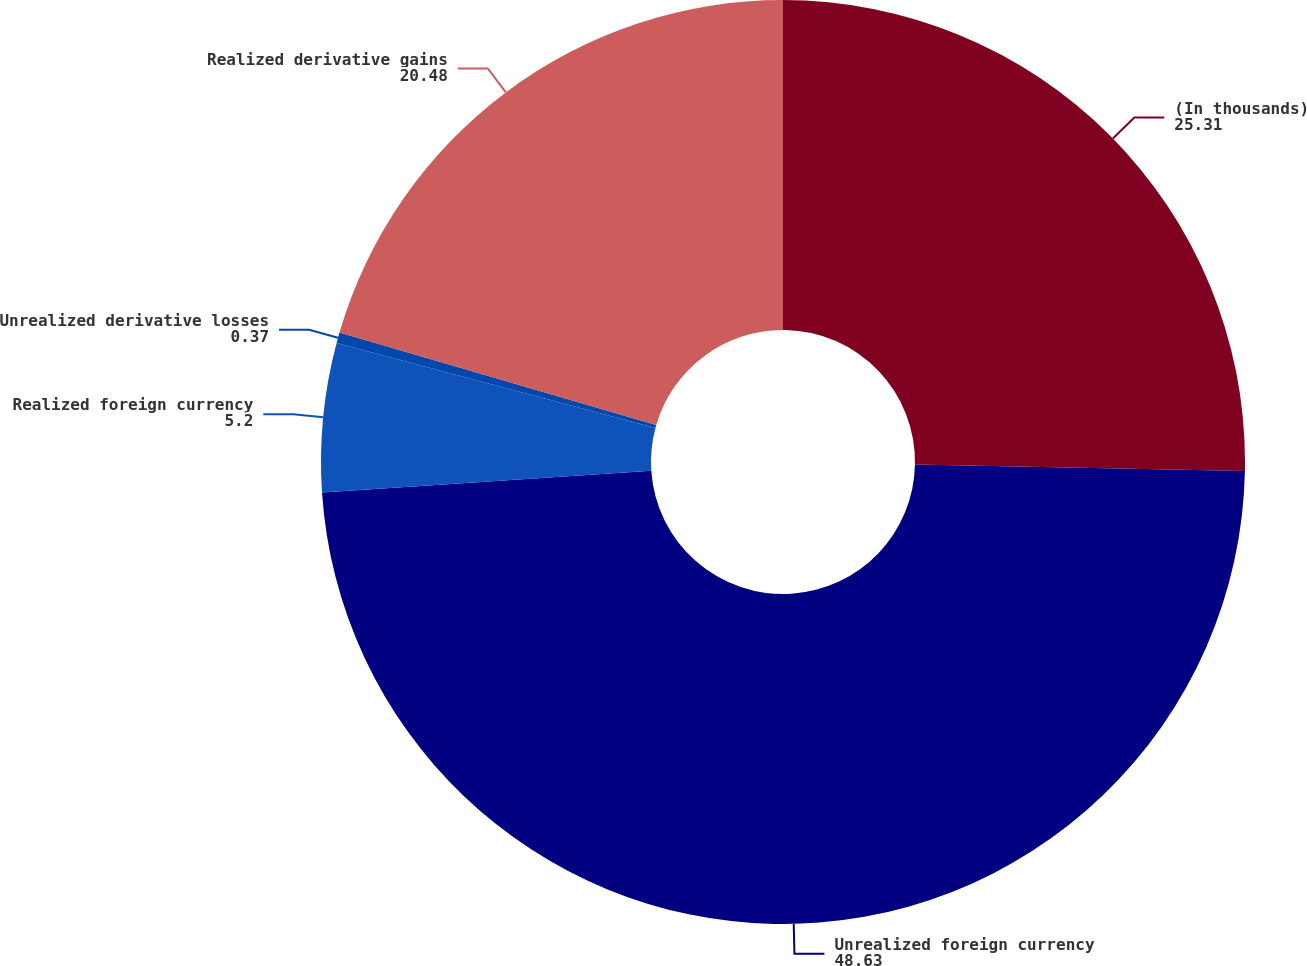<chart> <loc_0><loc_0><loc_500><loc_500><pie_chart><fcel>(In thousands)<fcel>Unrealized foreign currency<fcel>Realized foreign currency<fcel>Unrealized derivative losses<fcel>Realized derivative gains<nl><fcel>25.31%<fcel>48.63%<fcel>5.2%<fcel>0.37%<fcel>20.48%<nl></chart> 